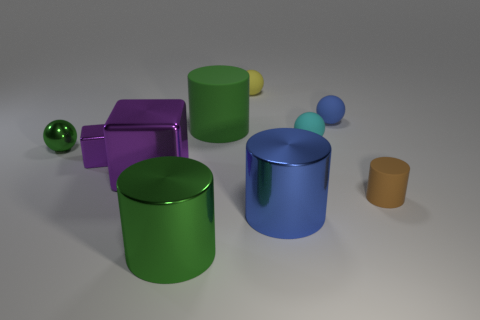What is the shape of the small rubber thing that is both in front of the blue rubber sphere and behind the small green metal object?
Your response must be concise. Sphere. Are there any small green shiny objects of the same shape as the green matte object?
Your response must be concise. No. There is a cylinder in front of the big blue metal cylinder; is it the same size as the rubber ball behind the tiny blue thing?
Your answer should be very brief. No. Are there more yellow matte balls than big brown rubber balls?
Your response must be concise. Yes. How many tiny things have the same material as the green ball?
Your response must be concise. 1. Do the cyan matte object and the big blue thing have the same shape?
Ensure brevity in your answer.  No. There is a green cylinder that is in front of the matte cylinder that is right of the big green object that is behind the brown matte cylinder; what is its size?
Your response must be concise. Large. There is a cube that is right of the tiny cube; are there any tiny shiny blocks that are to the right of it?
Offer a very short reply. No. There is a metal cylinder behind the green cylinder that is in front of the large block; how many rubber cylinders are to the right of it?
Give a very brief answer. 1. The tiny thing that is both in front of the small green metal ball and left of the yellow rubber ball is what color?
Offer a very short reply. Purple. 